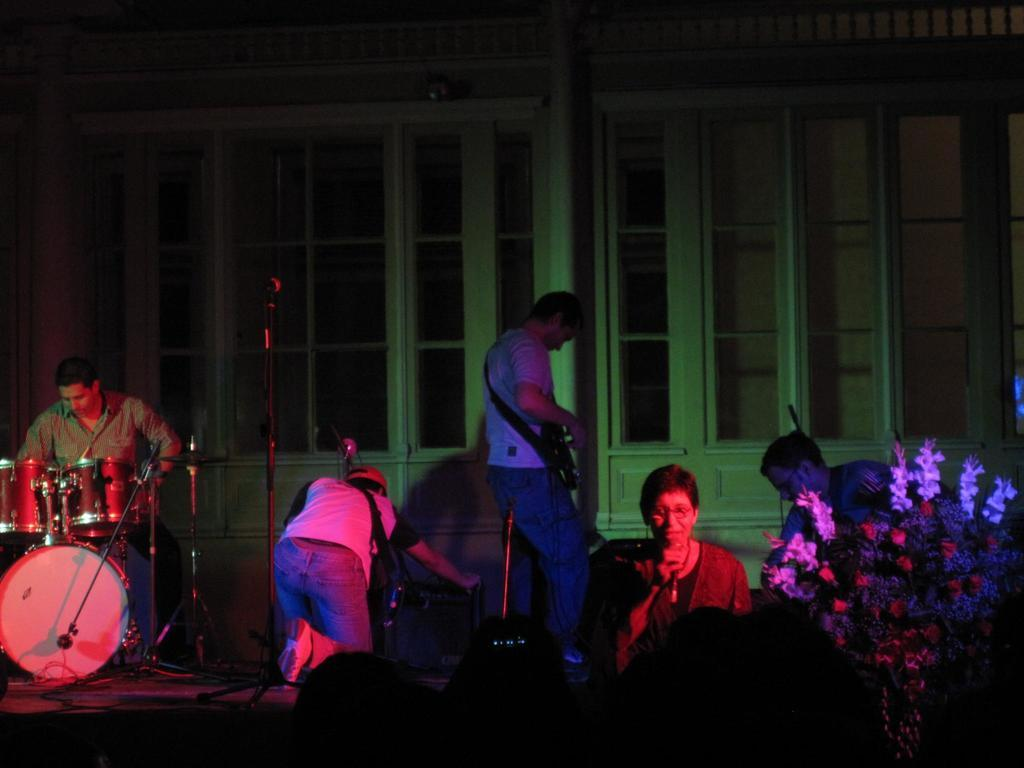What is the man in the image doing? The man is beating drums in the image. What is the woman in the image doing? The woman is singing on a microphone in the image. What can be seen on the right side of the image? There is a tree on the right side of the image. What type of volleyball game is being played in the image? There is no volleyball game present in the image. How does the earth appear in the image? The image does not show the earth; it only shows a man beating drums, a woman singing on a microphone, and a tree on the right side. 